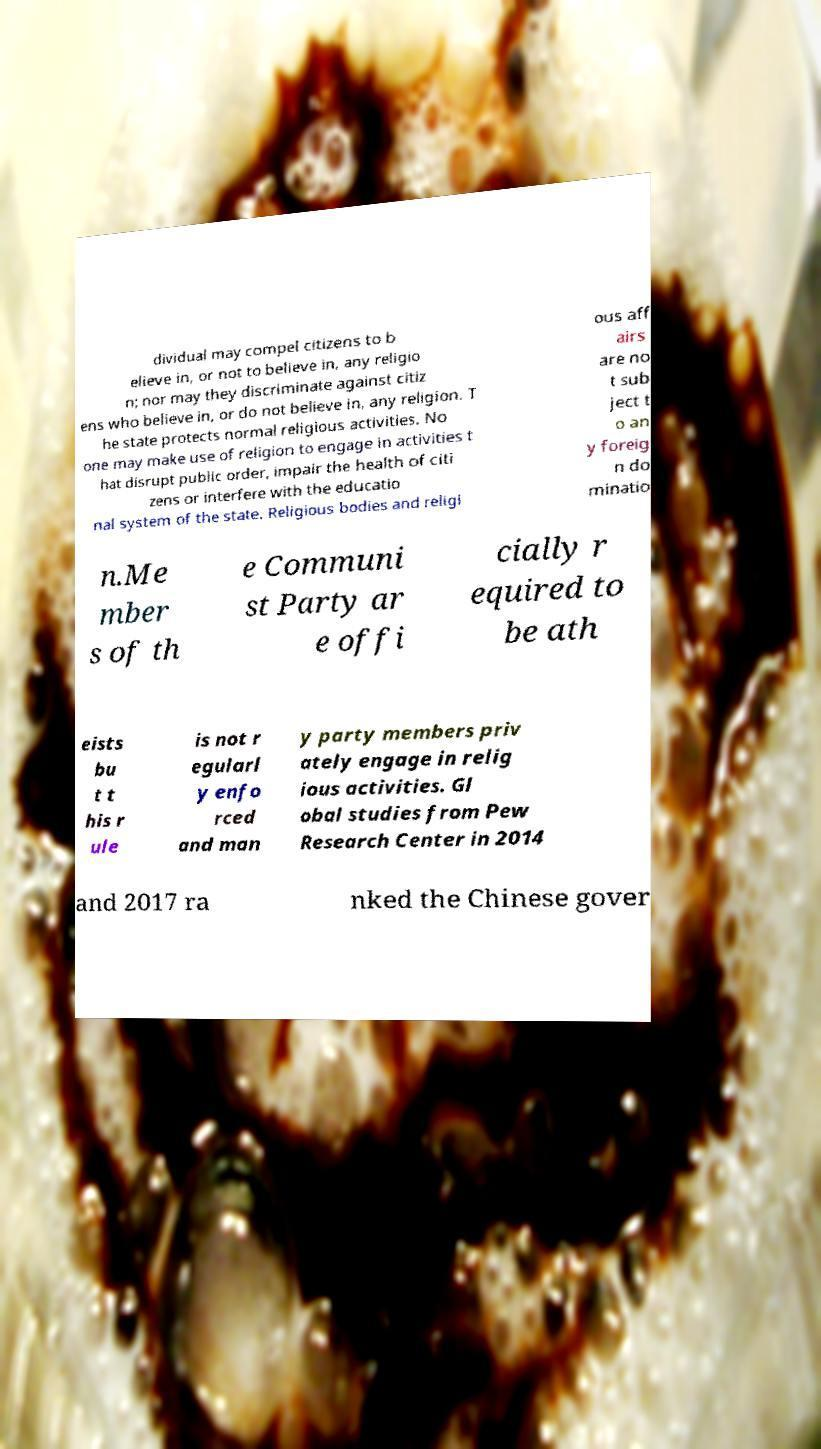Can you read and provide the text displayed in the image?This photo seems to have some interesting text. Can you extract and type it out for me? dividual may compel citizens to b elieve in, or not to believe in, any religio n; nor may they discriminate against citiz ens who believe in, or do not believe in, any religion. T he state protects normal religious activities. No one may make use of religion to engage in activities t hat disrupt public order, impair the health of citi zens or interfere with the educatio nal system of the state. Religious bodies and religi ous aff airs are no t sub ject t o an y foreig n do minatio n.Me mber s of th e Communi st Party ar e offi cially r equired to be ath eists bu t t his r ule is not r egularl y enfo rced and man y party members priv ately engage in relig ious activities. Gl obal studies from Pew Research Center in 2014 and 2017 ra nked the Chinese gover 